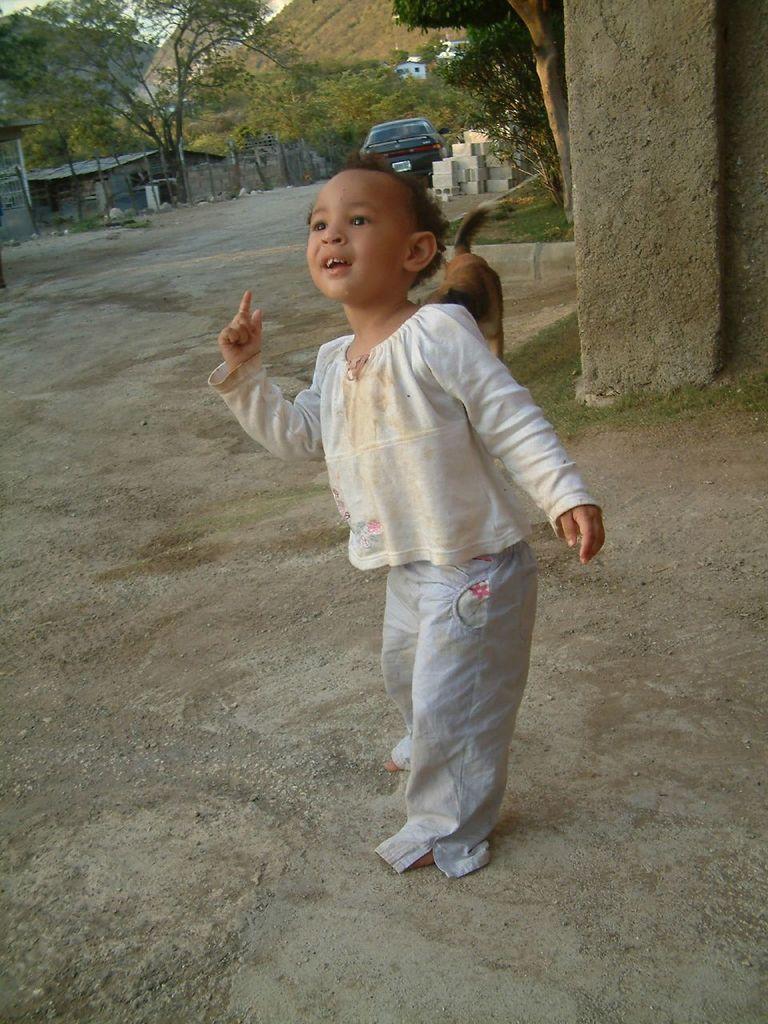In one or two sentences, can you explain what this image depicts? In this picture we can see a little kid standing on the ground and looking at someone. 